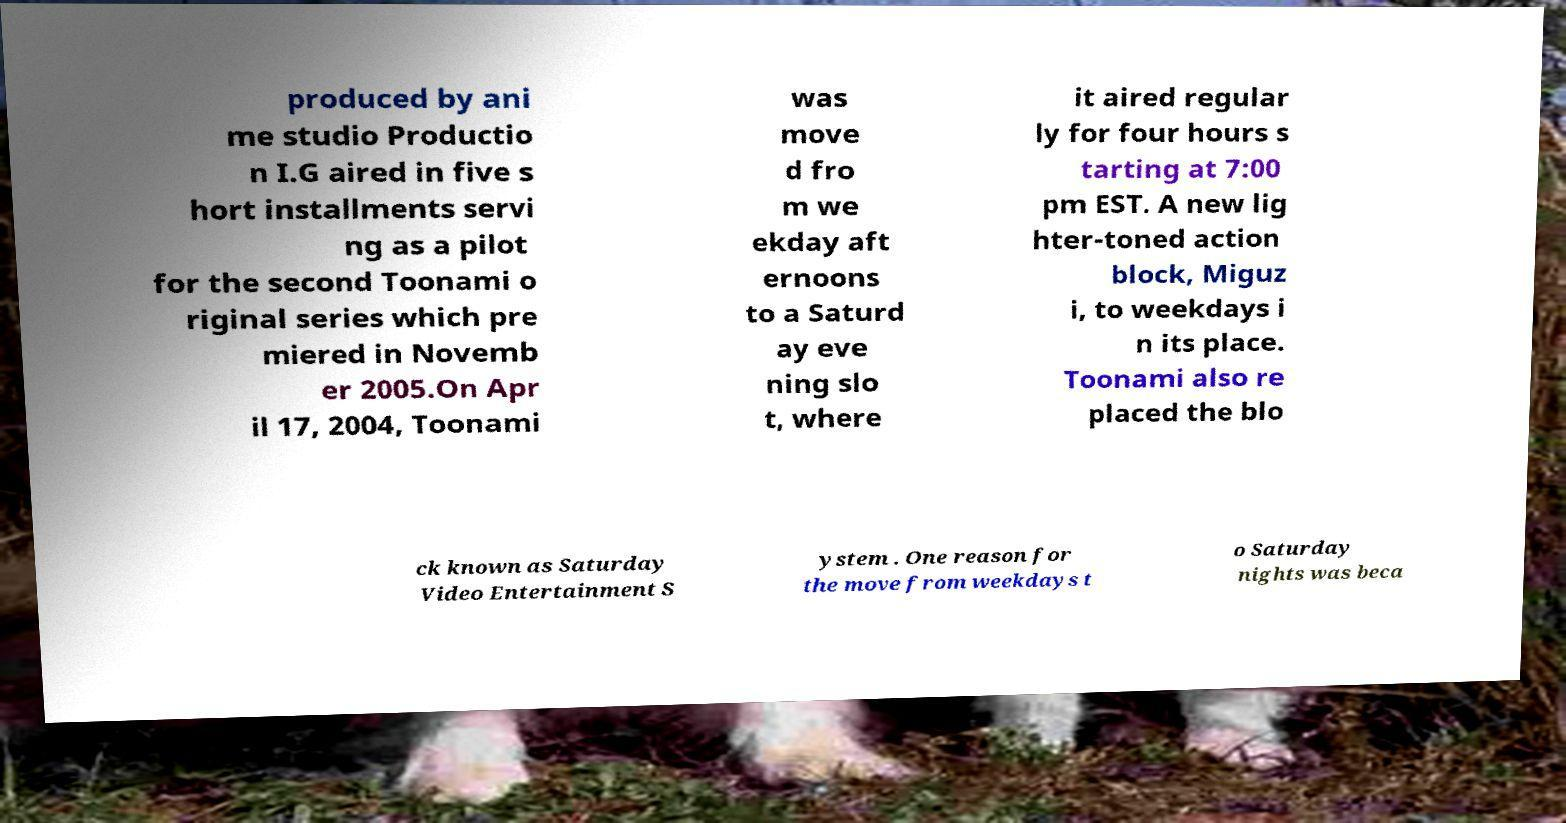Can you accurately transcribe the text from the provided image for me? produced by ani me studio Productio n I.G aired in five s hort installments servi ng as a pilot for the second Toonami o riginal series which pre miered in Novemb er 2005.On Apr il 17, 2004, Toonami was move d fro m we ekday aft ernoons to a Saturd ay eve ning slo t, where it aired regular ly for four hours s tarting at 7:00 pm EST. A new lig hter-toned action block, Miguz i, to weekdays i n its place. Toonami also re placed the blo ck known as Saturday Video Entertainment S ystem . One reason for the move from weekdays t o Saturday nights was beca 